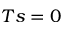<formula> <loc_0><loc_0><loc_500><loc_500>T s = 0</formula> 